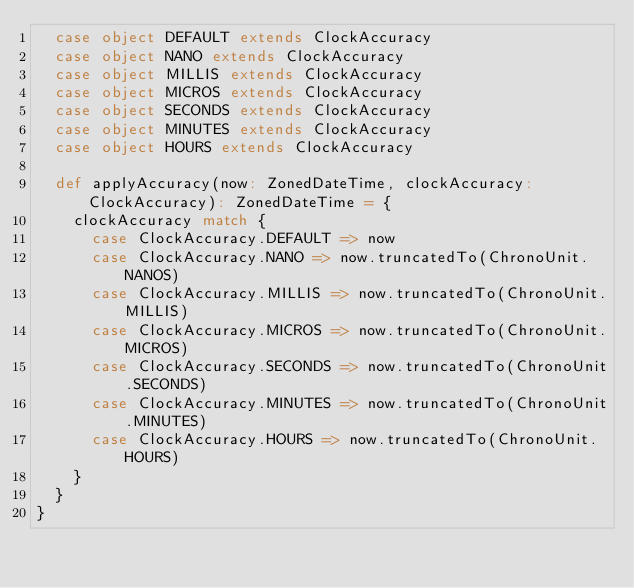<code> <loc_0><loc_0><loc_500><loc_500><_Scala_>  case object DEFAULT extends ClockAccuracy
  case object NANO extends ClockAccuracy
  case object MILLIS extends ClockAccuracy
  case object MICROS extends ClockAccuracy
  case object SECONDS extends ClockAccuracy
  case object MINUTES extends ClockAccuracy
  case object HOURS extends ClockAccuracy

  def applyAccuracy(now: ZonedDateTime, clockAccuracy: ClockAccuracy): ZonedDateTime = {
    clockAccuracy match {
      case ClockAccuracy.DEFAULT => now
      case ClockAccuracy.NANO => now.truncatedTo(ChronoUnit.NANOS)
      case ClockAccuracy.MILLIS => now.truncatedTo(ChronoUnit.MILLIS)
      case ClockAccuracy.MICROS => now.truncatedTo(ChronoUnit.MICROS)
      case ClockAccuracy.SECONDS => now.truncatedTo(ChronoUnit.SECONDS)
      case ClockAccuracy.MINUTES => now.truncatedTo(ChronoUnit.MINUTES)
      case ClockAccuracy.HOURS => now.truncatedTo(ChronoUnit.HOURS)
    }
  }
}
</code> 